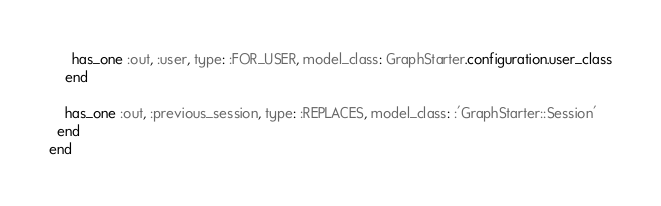<code> <loc_0><loc_0><loc_500><loc_500><_Ruby_>      has_one :out, :user, type: :FOR_USER, model_class: GraphStarter.configuration.user_class
    end

    has_one :out, :previous_session, type: :REPLACES, model_class: :'GraphStarter::Session'
  end
end

</code> 